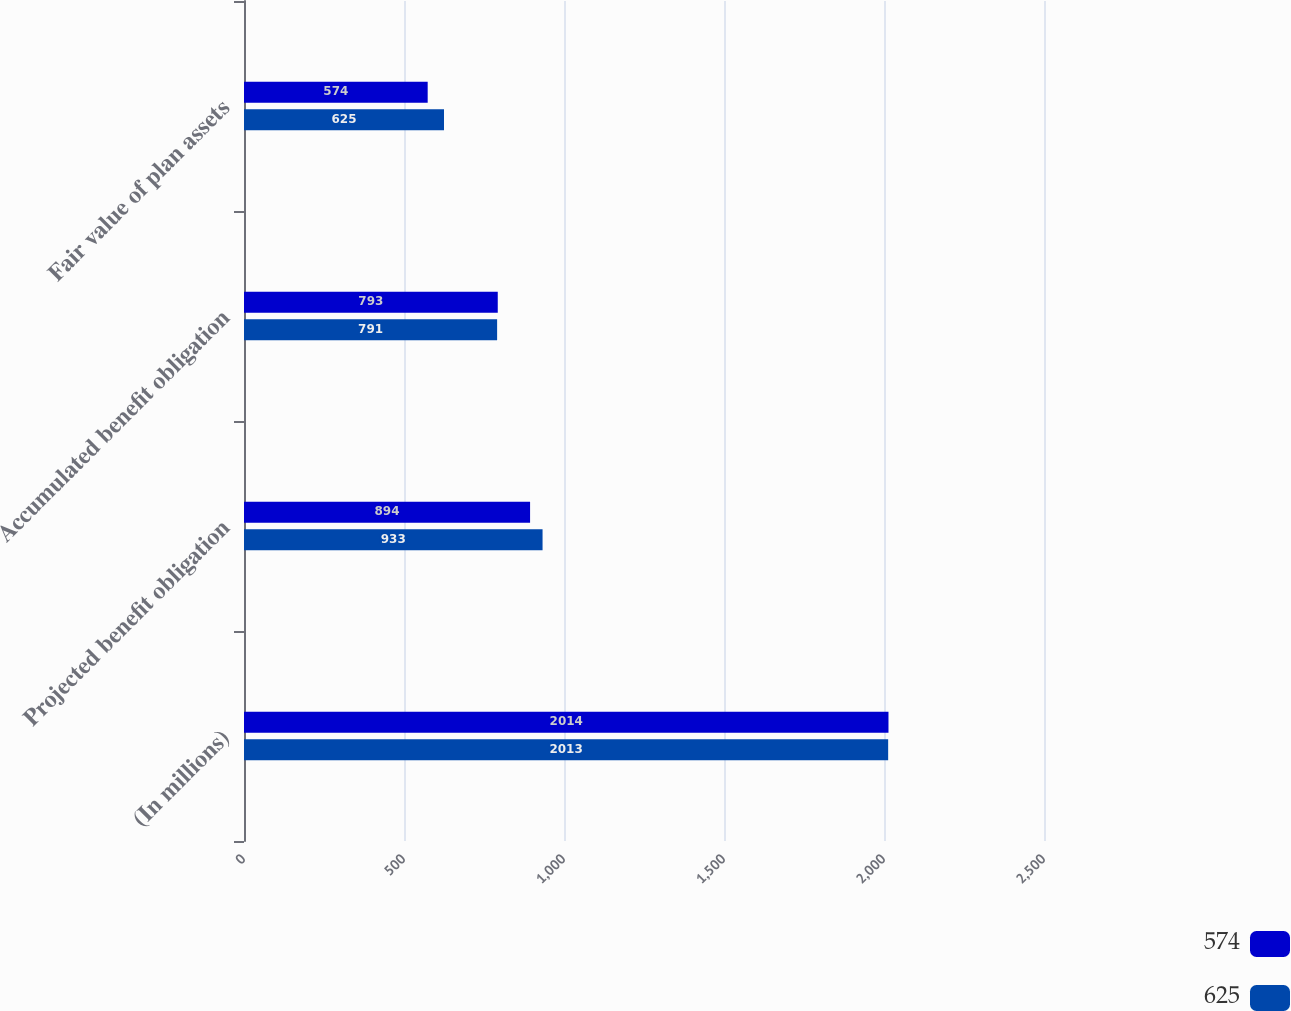Convert chart to OTSL. <chart><loc_0><loc_0><loc_500><loc_500><stacked_bar_chart><ecel><fcel>(In millions)<fcel>Projected benefit obligation<fcel>Accumulated benefit obligation<fcel>Fair value of plan assets<nl><fcel>574<fcel>2014<fcel>894<fcel>793<fcel>574<nl><fcel>625<fcel>2013<fcel>933<fcel>791<fcel>625<nl></chart> 